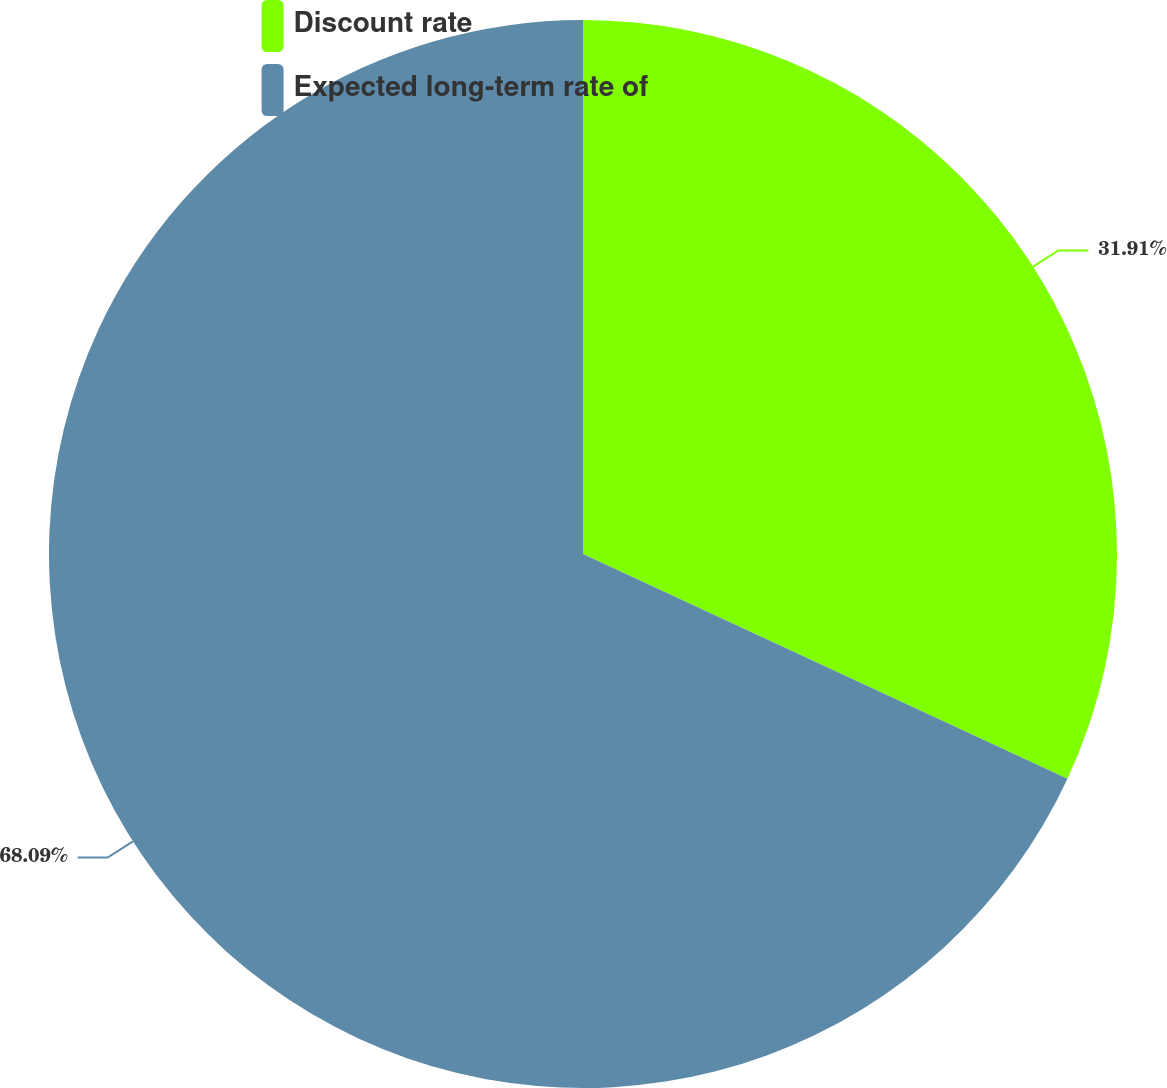Convert chart to OTSL. <chart><loc_0><loc_0><loc_500><loc_500><pie_chart><fcel>Discount rate<fcel>Expected long-term rate of<nl><fcel>31.91%<fcel>68.09%<nl></chart> 